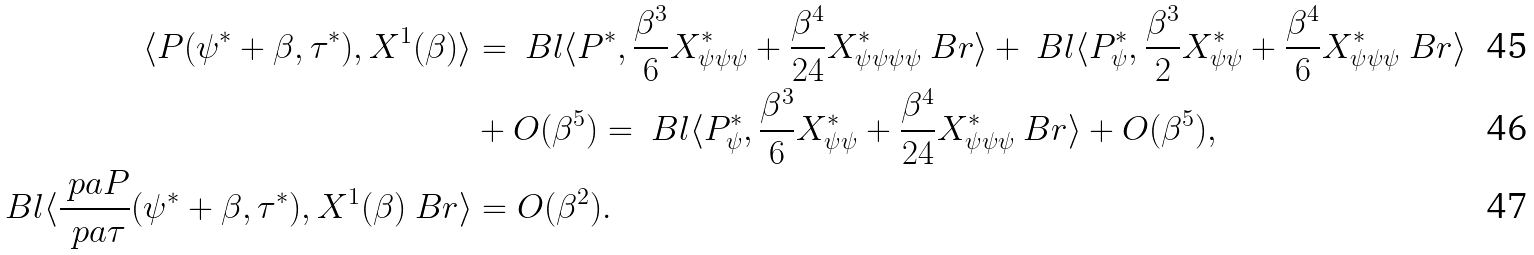Convert formula to latex. <formula><loc_0><loc_0><loc_500><loc_500>\langle P ( \psi ^ { * } + \beta , \tau ^ { * } ) , X ^ { 1 } ( \beta ) \rangle & = \ B l \langle P ^ { * } , \frac { \beta ^ { 3 } } { 6 } X ^ { * } _ { \psi \psi \psi } + \frac { \beta ^ { 4 } } { 2 4 } X ^ { * } _ { \psi \psi \psi \psi } \ B r \rangle + \ B l \langle P _ { \psi } ^ { * } , \frac { \beta ^ { 3 } } { 2 } X ^ { * } _ { \psi \psi } + \frac { \beta ^ { 4 } } { 6 } X ^ { * } _ { \psi \psi \psi } \ B r \rangle \\ & + O ( \beta ^ { 5 } ) = \ B l \langle P _ { \psi } ^ { * } , \frac { \beta ^ { 3 } } { 6 } X ^ { * } _ { \psi \psi } + \frac { \beta ^ { 4 } } { 2 4 } X ^ { * } _ { \psi \psi \psi } \ B r \rangle + O ( \beta ^ { 5 } ) , \\ \ B l \langle \frac { \ p a P } { \ p a \tau } ( \psi ^ { * } + \beta , \tau ^ { * } ) , X ^ { 1 } ( \beta ) \ B r \rangle & = O ( \beta ^ { 2 } ) .</formula> 